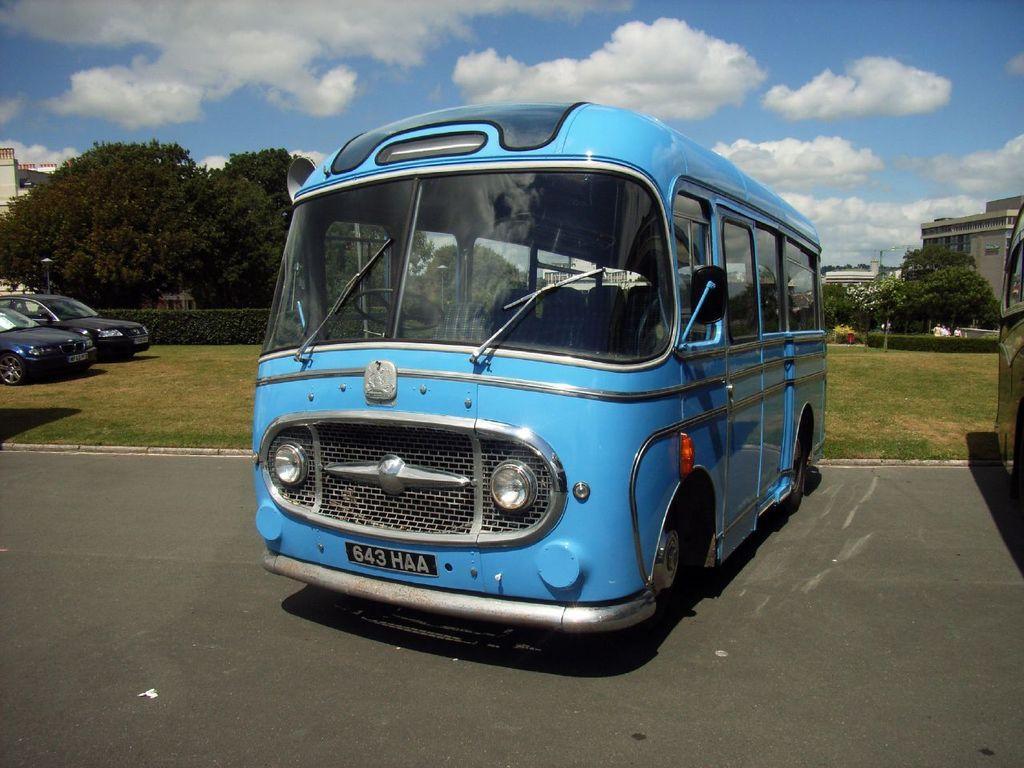Please provide a concise description of this image. In the background we can see the clouds in the sky. In this picture we can see the buildings, trees, people, grass, plants and vehicles. On the right side of the picture we can see the partial part of a vehicle. At the bottom portion of the picture we can see the road. 